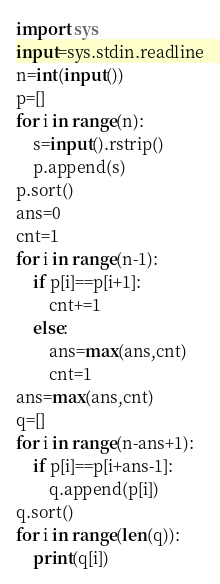<code> <loc_0><loc_0><loc_500><loc_500><_Python_>import sys
input=sys.stdin.readline
n=int(input())
p=[]
for i in range(n):
	s=input().rstrip()
	p.append(s)
p.sort()
ans=0
cnt=1
for i in range(n-1):
	if p[i]==p[i+1]:
		cnt+=1
	else:
		ans=max(ans,cnt)
		cnt=1
ans=max(ans,cnt)
q=[]
for i in range(n-ans+1):
	if p[i]==p[i+ans-1]:
		q.append(p[i])
q.sort()
for i in range(len(q)):
	print(q[i])
</code> 